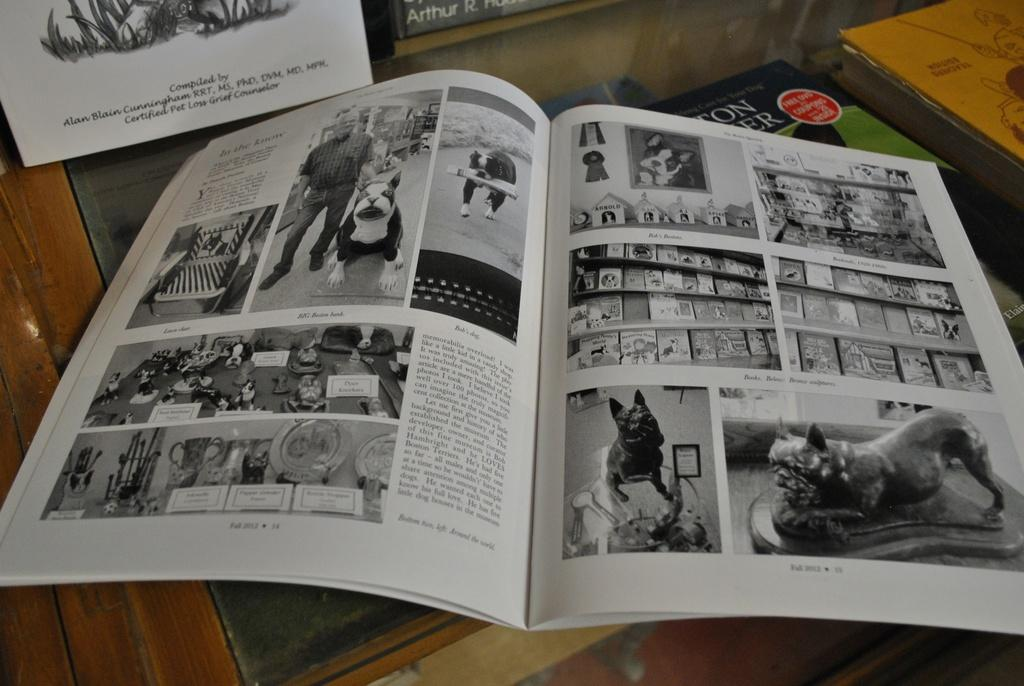<image>
Present a compact description of the photo's key features. An open book with pictures and another behind it that was completed by Alan Blain Cunningham. 